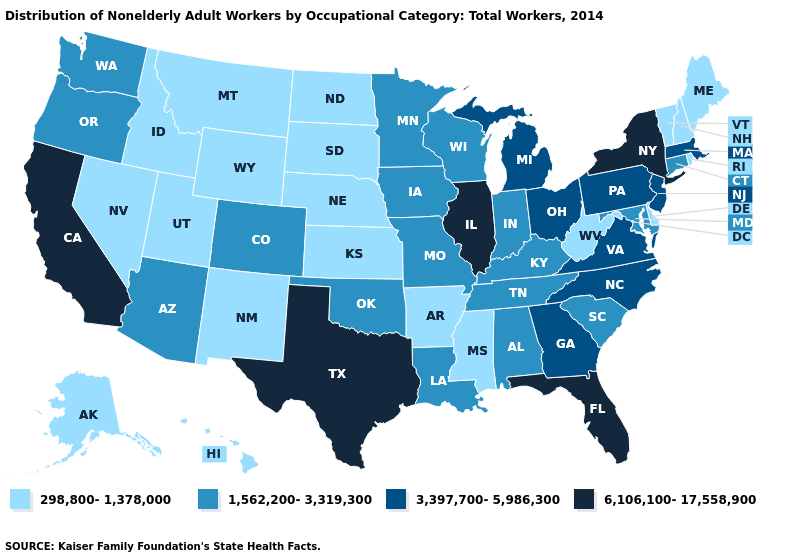Which states hav the highest value in the West?
Concise answer only. California. What is the value of New Hampshire?
Answer briefly. 298,800-1,378,000. Name the states that have a value in the range 6,106,100-17,558,900?
Write a very short answer. California, Florida, Illinois, New York, Texas. Does the first symbol in the legend represent the smallest category?
Keep it brief. Yes. What is the value of North Carolina?
Be succinct. 3,397,700-5,986,300. Which states have the lowest value in the MidWest?
Answer briefly. Kansas, Nebraska, North Dakota, South Dakota. Which states have the lowest value in the USA?
Keep it brief. Alaska, Arkansas, Delaware, Hawaii, Idaho, Kansas, Maine, Mississippi, Montana, Nebraska, Nevada, New Hampshire, New Mexico, North Dakota, Rhode Island, South Dakota, Utah, Vermont, West Virginia, Wyoming. Name the states that have a value in the range 1,562,200-3,319,300?
Answer briefly. Alabama, Arizona, Colorado, Connecticut, Indiana, Iowa, Kentucky, Louisiana, Maryland, Minnesota, Missouri, Oklahoma, Oregon, South Carolina, Tennessee, Washington, Wisconsin. Does Iowa have a lower value than New Jersey?
Keep it brief. Yes. What is the value of Kansas?
Give a very brief answer. 298,800-1,378,000. What is the value of Missouri?
Concise answer only. 1,562,200-3,319,300. Is the legend a continuous bar?
Short answer required. No. Name the states that have a value in the range 3,397,700-5,986,300?
Concise answer only. Georgia, Massachusetts, Michigan, New Jersey, North Carolina, Ohio, Pennsylvania, Virginia. What is the lowest value in states that border Arkansas?
Keep it brief. 298,800-1,378,000. 